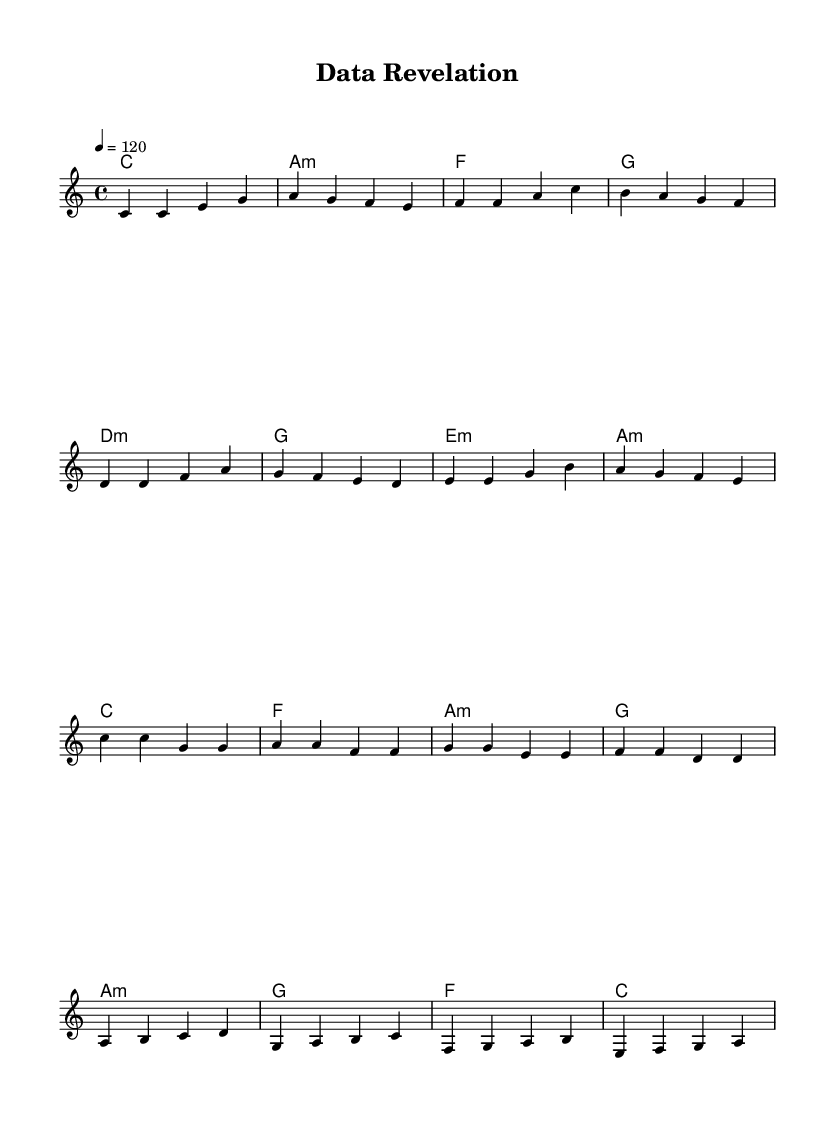What is the key signature of this music? The key signature is C major, which has no sharps or flats indicated at the beginning of the sheet music.
Answer: C major What is the time signature of this music? The time signature is indicated as 4/4, meaning there are four beats in each measure and the quarter note receives one beat.
Answer: 4/4 What is the tempo marking of this music? The tempo marking is indicated as "4 = 120," suggesting a moderate pace of 120 beats per minute for the quarter note.
Answer: 120 Which section follows the verse section? The sheet music shows an organized structure, and the Pre-Chorus comes directly after the verse, as outlined in the melody section.
Answer: Pre-Chorus What chord is used during the bridge section? By examining the chord progression under the bridge section, we can see the chords are a minor, G, F, and C, thus the chord used is F.
Answer: F In the chorus, how many distinct pitches are presented in the first measure? The first measure of the chorus includes two distinct pitches, both of which are C, making the total count two.
Answer: 2 What is the overall mood conveyed by this pop music piece? Analyzing the upbeat tempo, key, and chord progressions, this piece conveys an uplifting and positive vibe, typical of upbeat pop music.
Answer: Uplifting 